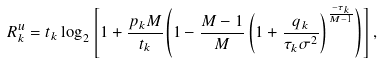Convert formula to latex. <formula><loc_0><loc_0><loc_500><loc_500>R ^ { u } _ { k } = t _ { k } \log _ { 2 } \left [ 1 + \frac { p _ { k } M } { t _ { k } } { \left ( 1 - \frac { M - 1 } { M } \left ( 1 + \frac { q _ { k } } { \tau _ { k } \sigma ^ { 2 } } \right ) ^ { \frac { - \tau _ { k } } { M - 1 } } \right ) } \right ] ,</formula> 